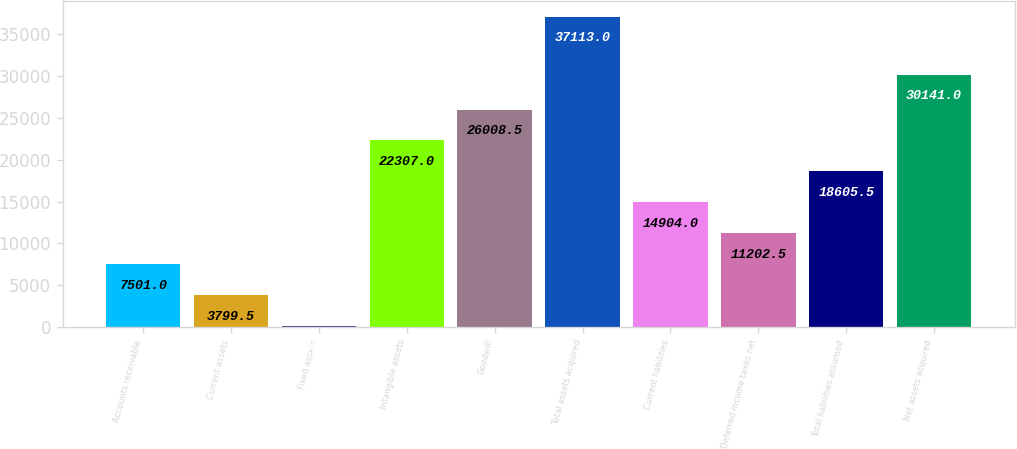Convert chart. <chart><loc_0><loc_0><loc_500><loc_500><bar_chart><fcel>Accounts receivable<fcel>Current assets<fcel>Fixed assets<fcel>Intangible assets<fcel>Goodwill<fcel>Total assets acquired<fcel>Current liabilities<fcel>Deferred income taxes net<fcel>Total liabilities assumed<fcel>Net assets acquired<nl><fcel>7501<fcel>3799.5<fcel>98<fcel>22307<fcel>26008.5<fcel>37113<fcel>14904<fcel>11202.5<fcel>18605.5<fcel>30141<nl></chart> 